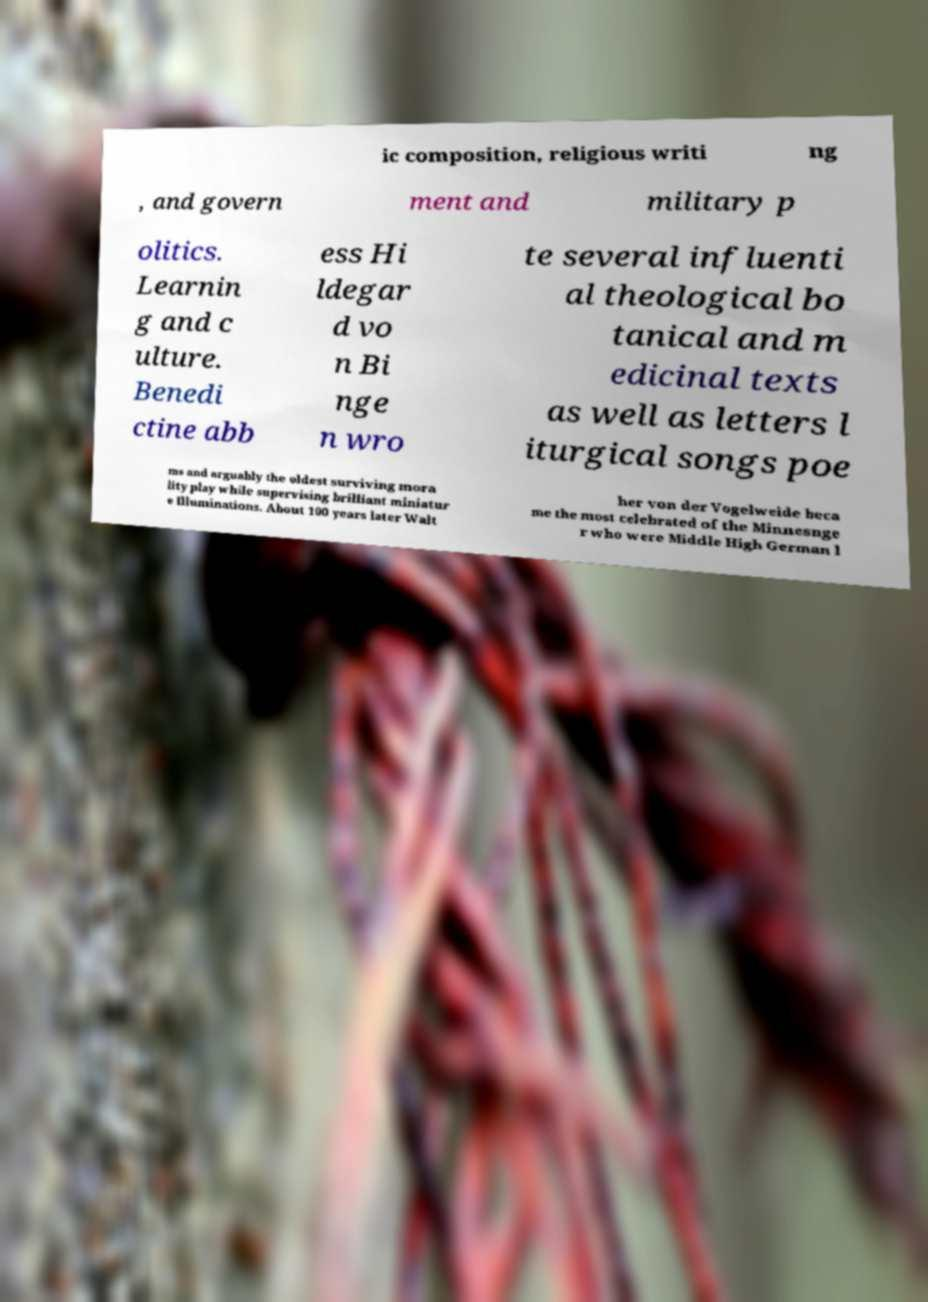I need the written content from this picture converted into text. Can you do that? ic composition, religious writi ng , and govern ment and military p olitics. Learnin g and c ulture. Benedi ctine abb ess Hi ldegar d vo n Bi nge n wro te several influenti al theological bo tanical and m edicinal texts as well as letters l iturgical songs poe ms and arguably the oldest surviving mora lity play while supervising brilliant miniatur e Illuminations. About 100 years later Walt her von der Vogelweide beca me the most celebrated of the Minnesnge r who were Middle High German l 